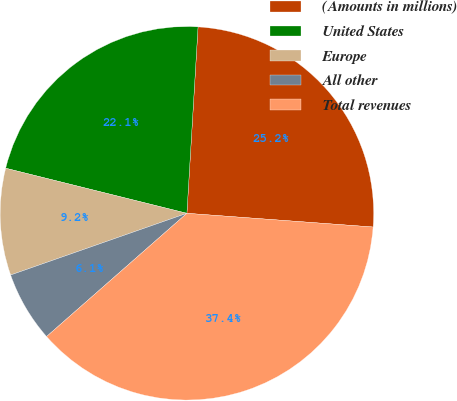Convert chart to OTSL. <chart><loc_0><loc_0><loc_500><loc_500><pie_chart><fcel>(Amounts in millions)<fcel>United States<fcel>Europe<fcel>All other<fcel>Total revenues<nl><fcel>25.22%<fcel>22.07%<fcel>9.24%<fcel>6.11%<fcel>37.36%<nl></chart> 